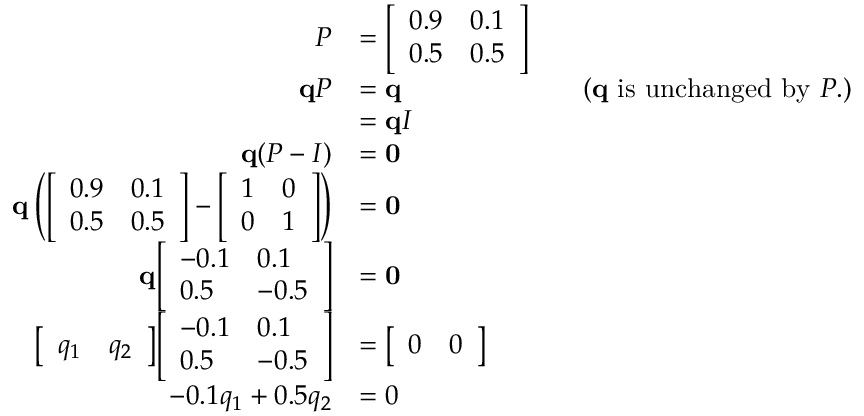<formula> <loc_0><loc_0><loc_500><loc_500>{ \begin{array} { r l r l } { P } & { = { \left [ \begin{array} { l l } { 0 . 9 } & { 0 . 1 } \\ { 0 . 5 } & { 0 . 5 } \end{array} \right ] } } \\ { q P } & { = q } & & { { ( } q { i s u n c h a n g e d b y } P { . ) } } \\ & { = q I } \\ { q ( P - I ) } & { = 0 } \\ { q \left ( { \left [ \begin{array} { l l } { 0 . 9 } & { 0 . 1 } \\ { 0 . 5 } & { 0 . 5 } \end{array} \right ] } - { \left [ \begin{array} { l l } { 1 } & { 0 } \\ { 0 } & { 1 } \end{array} \right ] } \right ) } & { = 0 } \\ { q { \left [ \begin{array} { l l } { - 0 . 1 } & { 0 . 1 } \\ { 0 . 5 } & { - 0 . 5 } \end{array} \right ] } } & { = 0 } \\ { { \left [ \begin{array} { l l } { q _ { 1 } } & { q _ { 2 } } \end{array} \right ] } { \left [ \begin{array} { l l } { - 0 . 1 } & { 0 . 1 } \\ { 0 . 5 } & { - 0 . 5 } \end{array} \right ] } } & { = { \left [ \begin{array} { l l } { 0 } & { 0 } \end{array} \right ] } } \\ { - 0 . 1 q _ { 1 } + 0 . 5 q _ { 2 } } & { = 0 } \end{array} }</formula> 